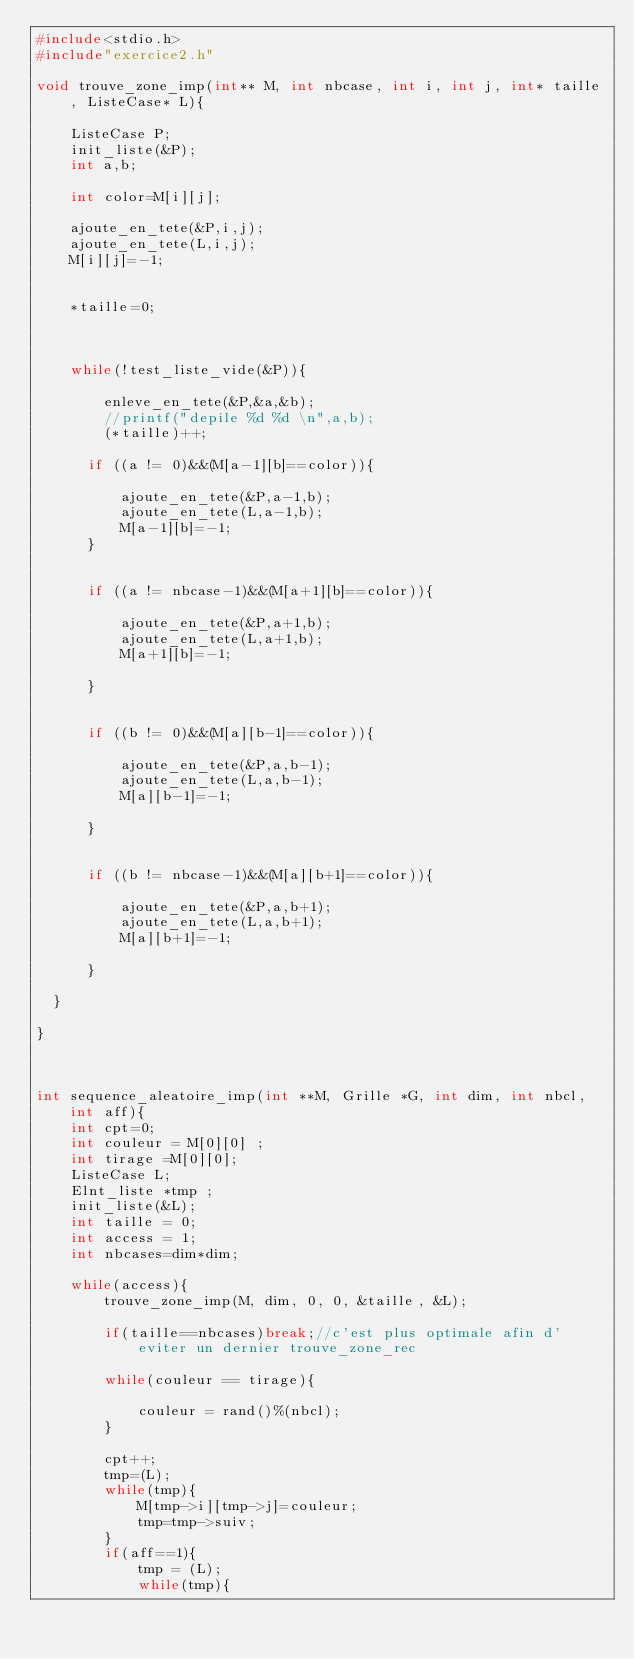<code> <loc_0><loc_0><loc_500><loc_500><_C_>#include<stdio.h>
#include"exercice2.h"

void trouve_zone_imp(int** M, int nbcase, int i, int j, int* taille, ListeCase* L){

    ListeCase P;
    init_liste(&P);
    int a,b;

    int color=M[i][j];

    ajoute_en_tete(&P,i,j);
    ajoute_en_tete(L,i,j);
    M[i][j]=-1;


    *taille=0;



    while(!test_liste_vide(&P)){

        enleve_en_tete(&P,&a,&b);
        //printf("depile %d %d \n",a,b);
        (*taille)++;

      if ((a != 0)&&(M[a-1][b]==color)){

          ajoute_en_tete(&P,a-1,b);
          ajoute_en_tete(L,a-1,b);
          M[a-1][b]=-1;
      }


      if ((a != nbcase-1)&&(M[a+1][b]==color)){

          ajoute_en_tete(&P,a+1,b);
          ajoute_en_tete(L,a+1,b);
          M[a+1][b]=-1;

      }


      if ((b != 0)&&(M[a][b-1]==color)){

          ajoute_en_tete(&P,a,b-1);
          ajoute_en_tete(L,a,b-1);
          M[a][b-1]=-1;

      }


      if ((b != nbcase-1)&&(M[a][b+1]==color)){

          ajoute_en_tete(&P,a,b+1);
          ajoute_en_tete(L,a,b+1);
          M[a][b+1]=-1;

      }

  }

}



int sequence_aleatoire_imp(int **M, Grille *G, int dim, int nbcl, int aff){
    int cpt=0;
    int couleur = M[0][0] ;
    int tirage =M[0][0];
    ListeCase L;
    Elnt_liste *tmp ;
    init_liste(&L);
    int taille = 0;
    int access = 1;
    int nbcases=dim*dim;
    
    while(access){
        trouve_zone_imp(M, dim, 0, 0, &taille, &L);
        
        if(taille==nbcases)break;//c'est plus optimale afin d'eviter un dernier trouve_zone_rec
        
        while(couleur == tirage){
        
            couleur = rand()%(nbcl);
        }
        
        cpt++;
        tmp=(L);
        while(tmp){
            M[tmp->i][tmp->j]=couleur;
            tmp=tmp->suiv;
        }
        if(aff==1){
            tmp = (L);
            while(tmp){</code> 